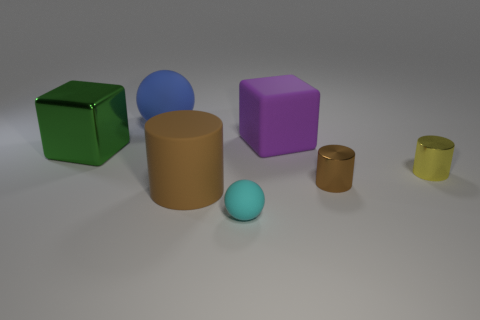How many brown cylinders must be subtracted to get 1 brown cylinders? 1 Add 1 metal cylinders. How many objects exist? 8 Subtract all green cubes. How many cubes are left? 1 Subtract all big brown cylinders. How many cylinders are left? 2 Subtract all spheres. How many objects are left? 5 Subtract all gray cubes. Subtract all gray balls. How many cubes are left? 2 Subtract all blue cubes. How many blue spheres are left? 1 Subtract all yellow matte cylinders. Subtract all big green metal blocks. How many objects are left? 6 Add 6 large green metal objects. How many large green metal objects are left? 7 Add 6 blue spheres. How many blue spheres exist? 7 